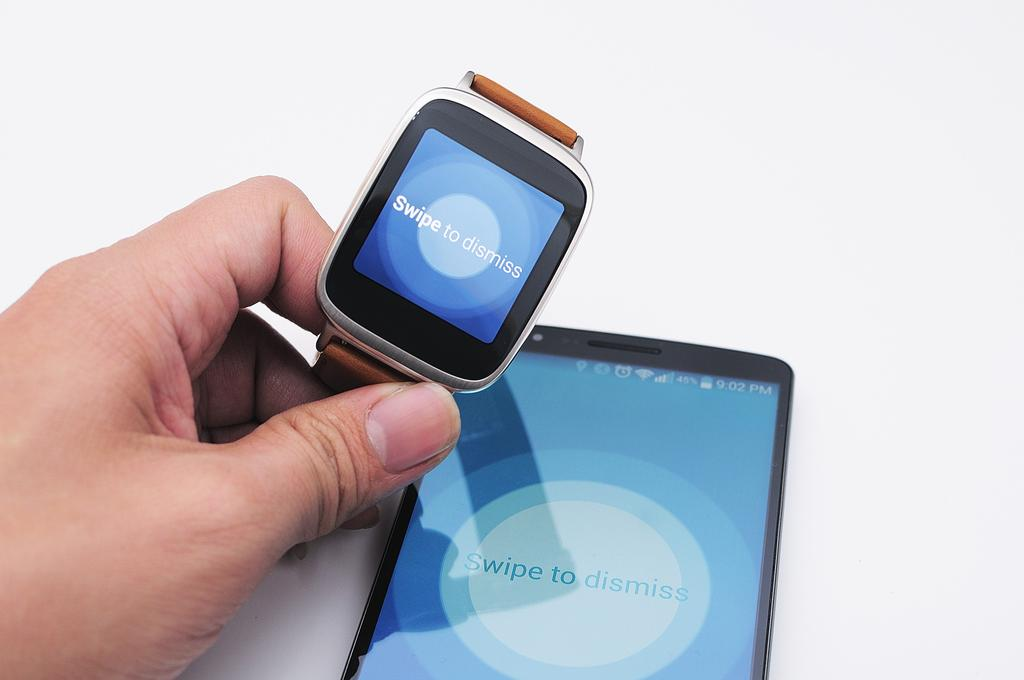<image>
Present a compact description of the photo's key features. Person holding a smart watch that says Swipe to dismiss on the screen. 